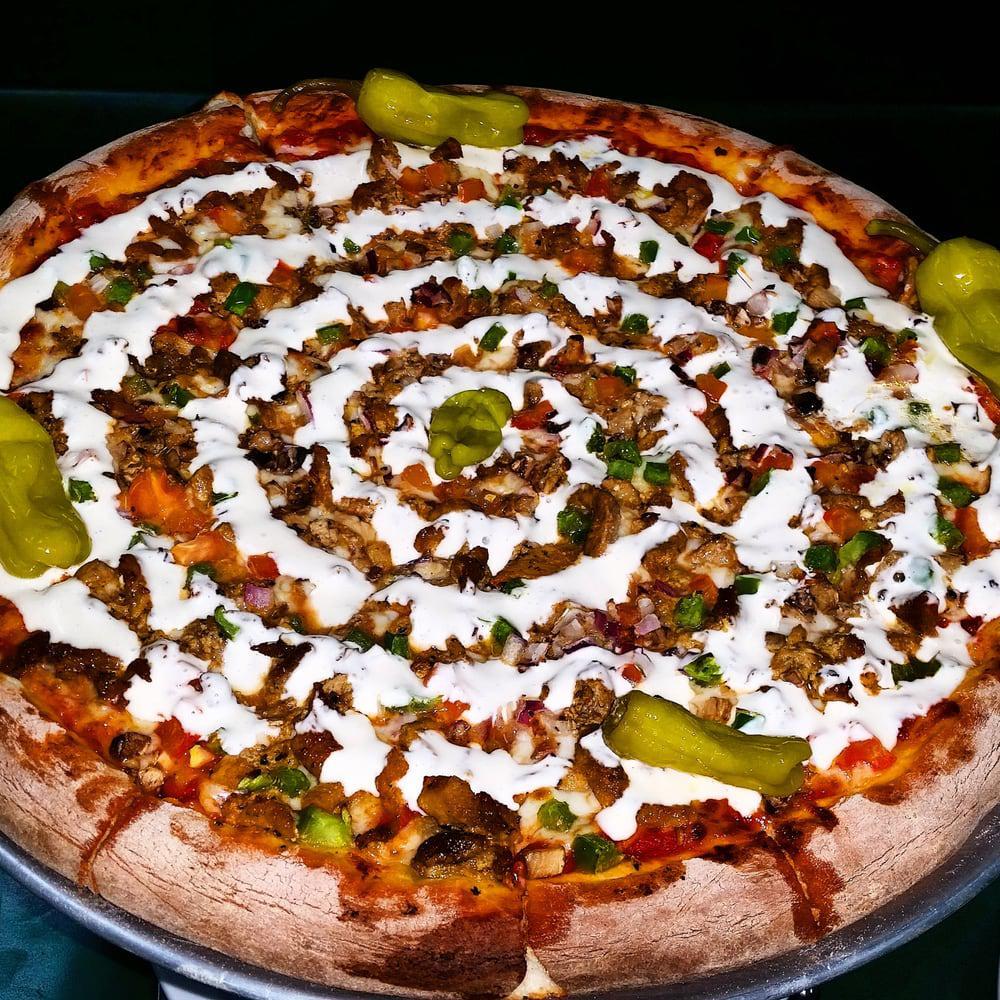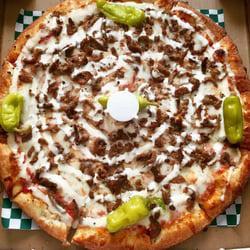The first image is the image on the left, the second image is the image on the right. Considering the images on both sides, is "Each image shows a whole round pizza topped with a spiral of white cheese, and at least one pizza has a green chile pepper on top." valid? Answer yes or no. Yes. 